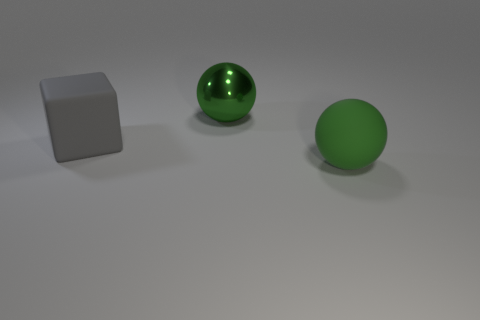Is the shape of the large green metallic object the same as the object in front of the gray rubber thing?
Give a very brief answer. Yes. What number of balls are both on the left side of the big matte sphere and to the right of the shiny sphere?
Your answer should be compact. 0. There is another green thing that is the same shape as the shiny object; what material is it?
Make the answer very short. Rubber. Is there a big green cube?
Offer a terse response. No. What is the large thing that is in front of the big shiny ball and right of the big block made of?
Your answer should be very brief. Rubber. Are there more large objects behind the big gray thing than gray cubes behind the large metallic ball?
Keep it short and to the point. Yes. Are there any gray matte objects of the same size as the rubber block?
Ensure brevity in your answer.  No. The metal sphere is what color?
Keep it short and to the point. Green. Is the number of large rubber cubes that are to the left of the green shiny ball greater than the number of green matte cylinders?
Keep it short and to the point. Yes. There is a green shiny object; what number of green things are in front of it?
Offer a very short reply. 1. 